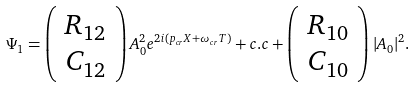Convert formula to latex. <formula><loc_0><loc_0><loc_500><loc_500>\Psi _ { 1 } = \left ( \begin{array} { c c } R _ { 1 2 } \\ C _ { 1 2 } \end{array} \right ) A _ { 0 } ^ { 2 } e ^ { 2 i ( p _ { c r } X + \omega _ { c r } T ) } + c . c + \left ( \begin{array} { c c } R _ { 1 0 } \\ C _ { 1 0 } \end{array} \right ) | A _ { 0 } | ^ { 2 } .</formula> 